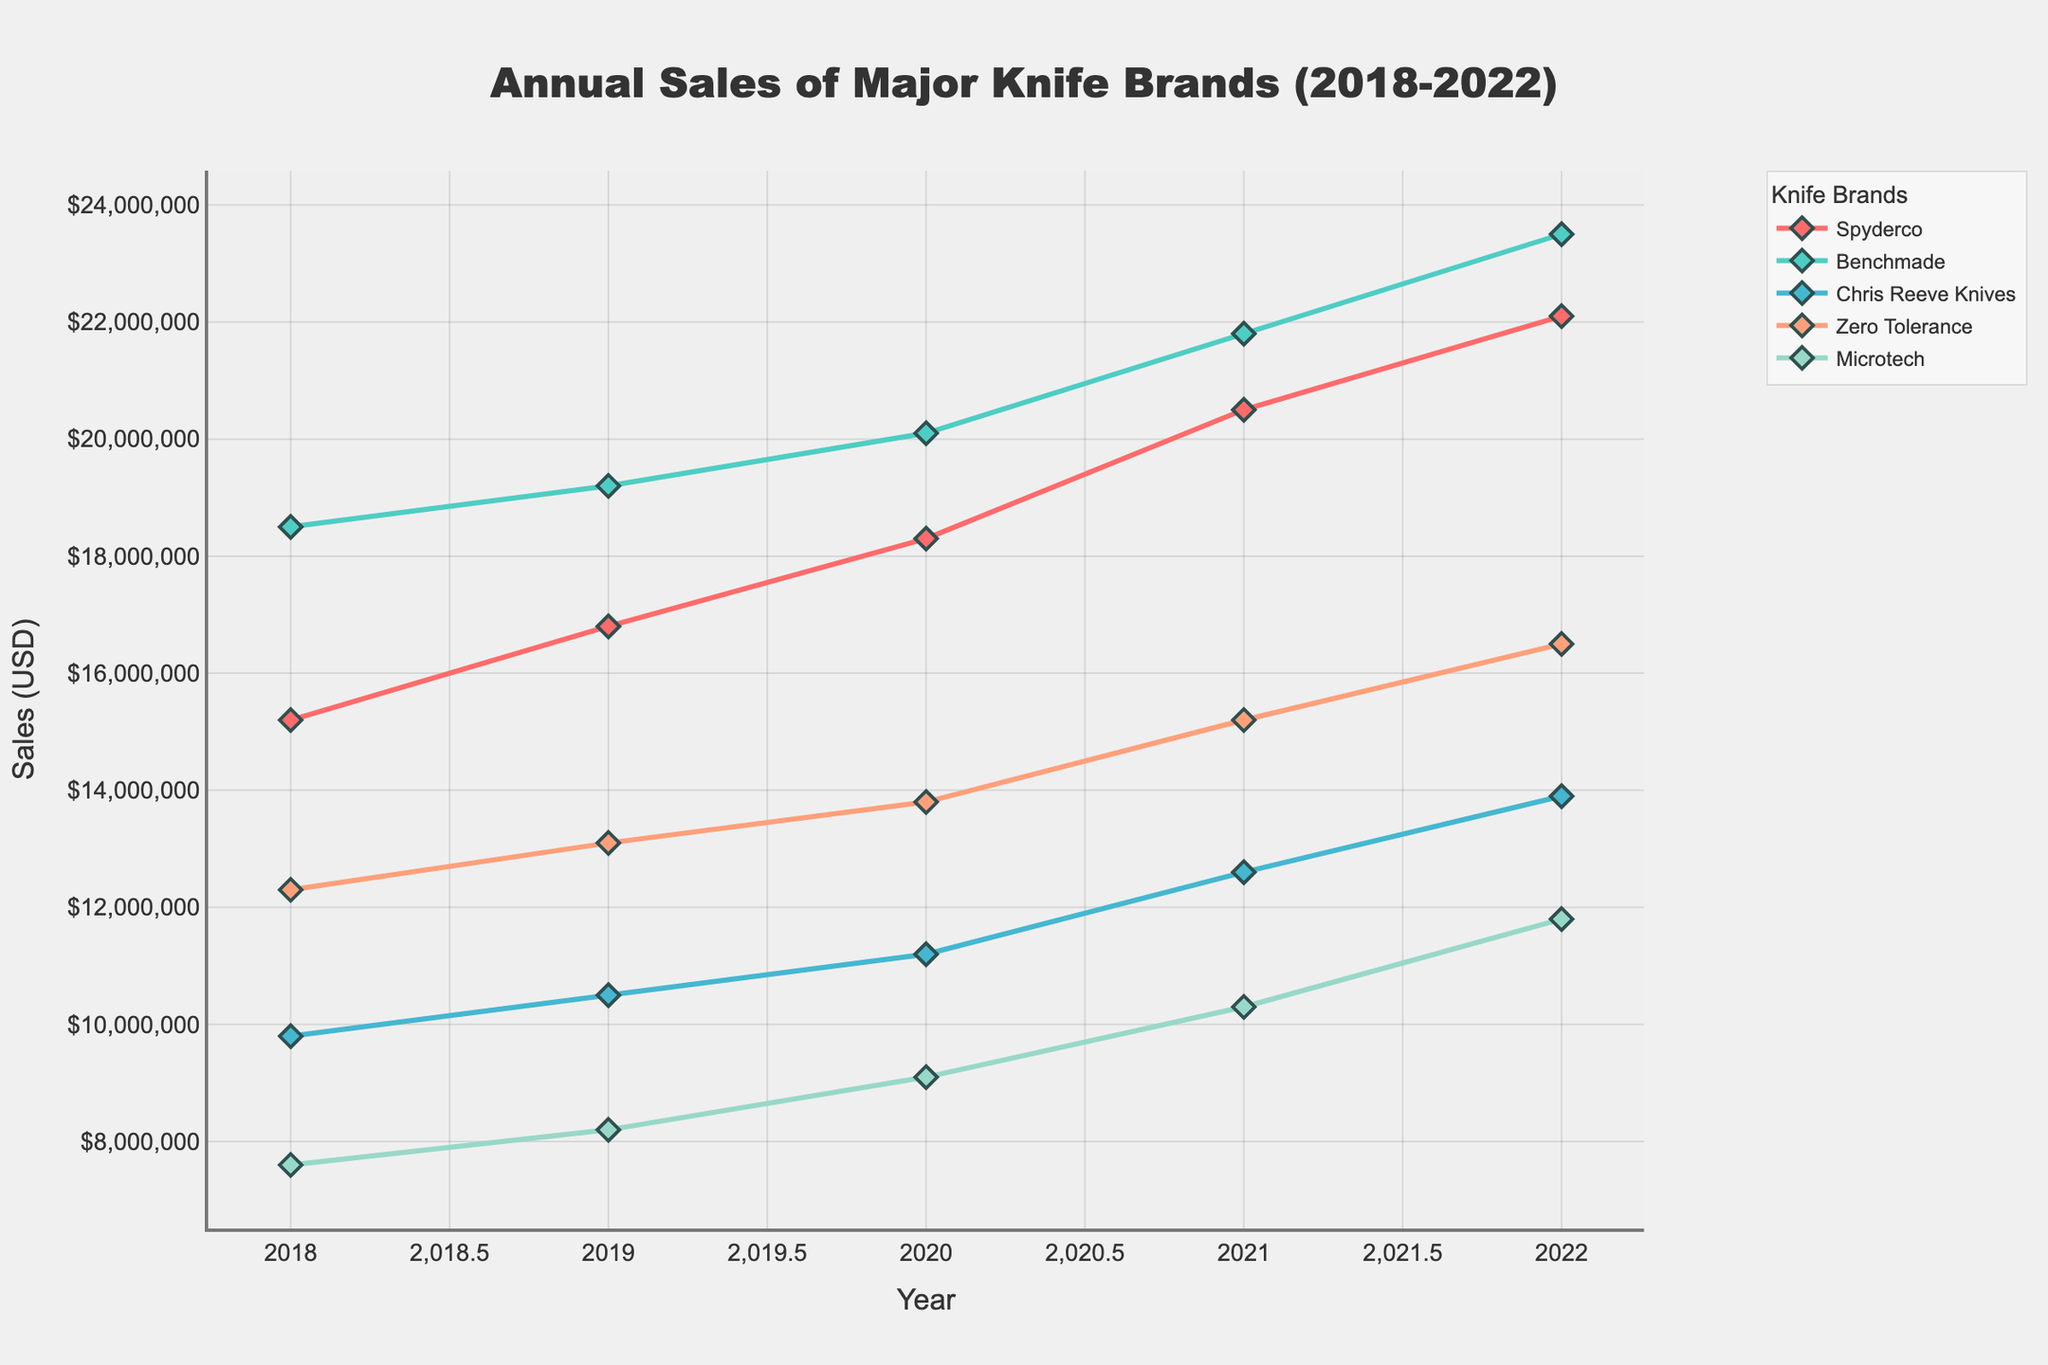Which brand had the highest sales in 2022? Look at the sales figures for 2022; Benchmade has the highest value among all the brands.
Answer: Benchmade How did Spyderco's sales change from 2020 to 2022? Find Spyderco’s sales in 2020 and 2022 and calculate the difference: \(22,100,000 - 18,300,000 = 3,800,000\).
Answer: Increased by $3,800,000 Which brand experienced the most significant sales growth between 2018 and 2022? Calculate the difference in sales for each brand between 2018 and 2022 and determine the highest: Chris Reeve Knives (13,900,000 - 9,800,000 = 4,100,000) has the most significant growth.
Answer: Chris Reeve Knives Compare the sales of Microtech in 2019 and Zero Tolerance in 2020. Which one is higher? Compare the values: Microtech in 2019 ($8,200,000) is less than Zero Tolerance in 2020 ($13,800,000).
Answer: Zero Tolerance in 2020 What was the average annual sales for Benchmade from 2018 to 2022? Sum the annual sales for Benchmade and divide by the number of years: \((18,500,000 + 19,200,000 + 20,100,000 + 21,800,000 + 23,500,000) / 5 = 20,420,000\).
Answer: $20,420,000 What is the total sales for all brands in 2021? Add the sales for each brand in 2021: \(20,500,000 + 21,800,000 + 12,600,000 + 15,200,000 + 10,300,000 = 80,400,000\).
Answer: $80,400,000 Did any brand experience a drop in sales during the period from 2018 to 2022? Examine the sales trend for each brand; none of the brands show a decrease in sales during this period.
Answer: No Which brand's sales line is represented by a green color? Identify the line by its color on the graph; Benchmade is represented by a green color.
Answer: Benchmade What is the difference between Spyderco's and Microtech's sales in 2022? Subtract Microtech’s sales from Spyderco’s sales in 2022: \(22,100,000 - 11,800,000 = 10,300,000\).
Answer: $10,300,000 When did Zero Tolerance's sales first exceed $15,000,000? Look at Zero Tolerance's sales across the years; it first exceeded $15,000,000 in 2022.
Answer: 2022 